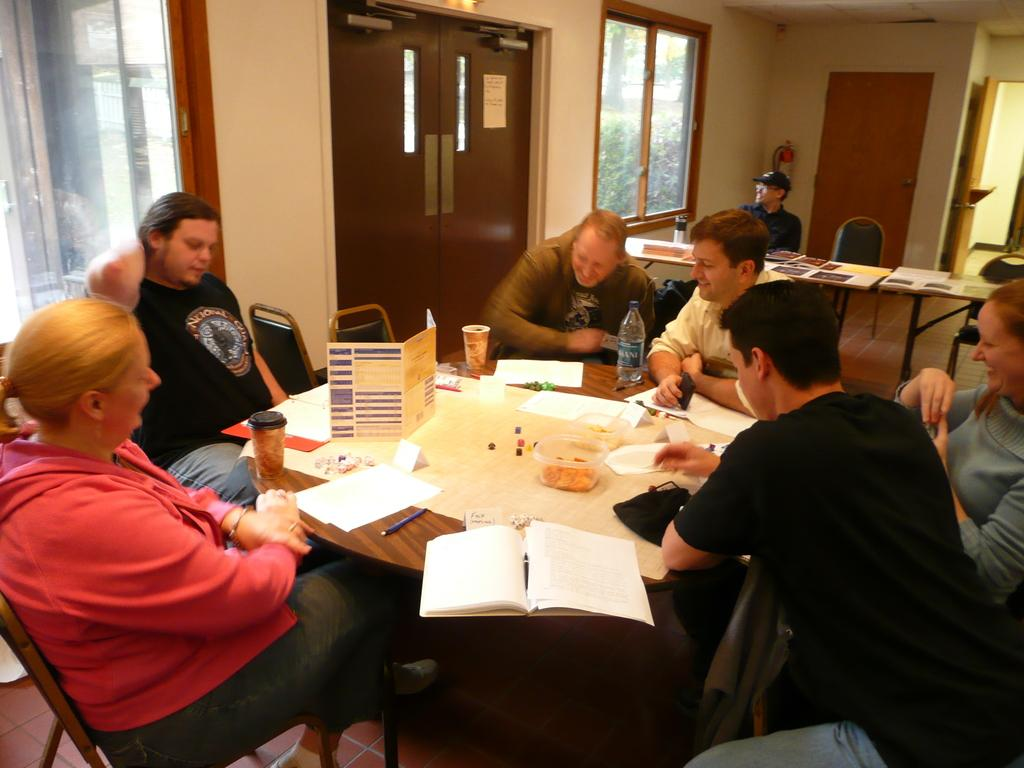What type of structure can be seen in the image? There is a wall in the image. What feature allows light and air to enter the room? There is a window in the image. How can someone enter or exit the room? There is a door in the image. What are the people in the image doing? There are people sitting on chairs in the image. What is on the table in the image? There is a table in the image with books, a box, papers, pens, a bottle, and a glass on it. What is the purpose of the thread in the image? There is no thread present in the image. How does the hand contribute to the scene in the image? There are no hands visible in the image. 